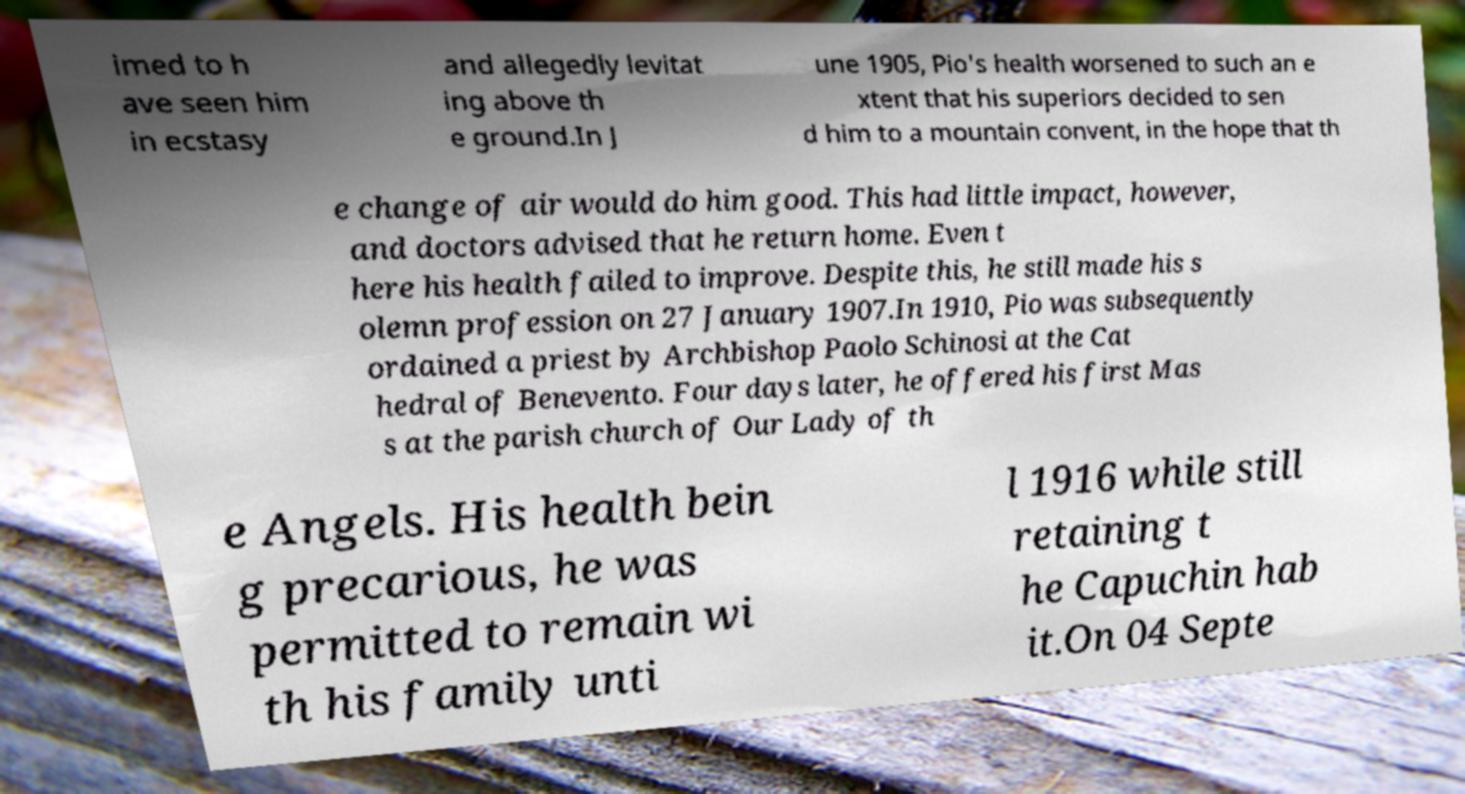Please identify and transcribe the text found in this image. imed to h ave seen him in ecstasy and allegedly levitat ing above th e ground.In J une 1905, Pio's health worsened to such an e xtent that his superiors decided to sen d him to a mountain convent, in the hope that th e change of air would do him good. This had little impact, however, and doctors advised that he return home. Even t here his health failed to improve. Despite this, he still made his s olemn profession on 27 January 1907.In 1910, Pio was subsequently ordained a priest by Archbishop Paolo Schinosi at the Cat hedral of Benevento. Four days later, he offered his first Mas s at the parish church of Our Lady of th e Angels. His health bein g precarious, he was permitted to remain wi th his family unti l 1916 while still retaining t he Capuchin hab it.On 04 Septe 